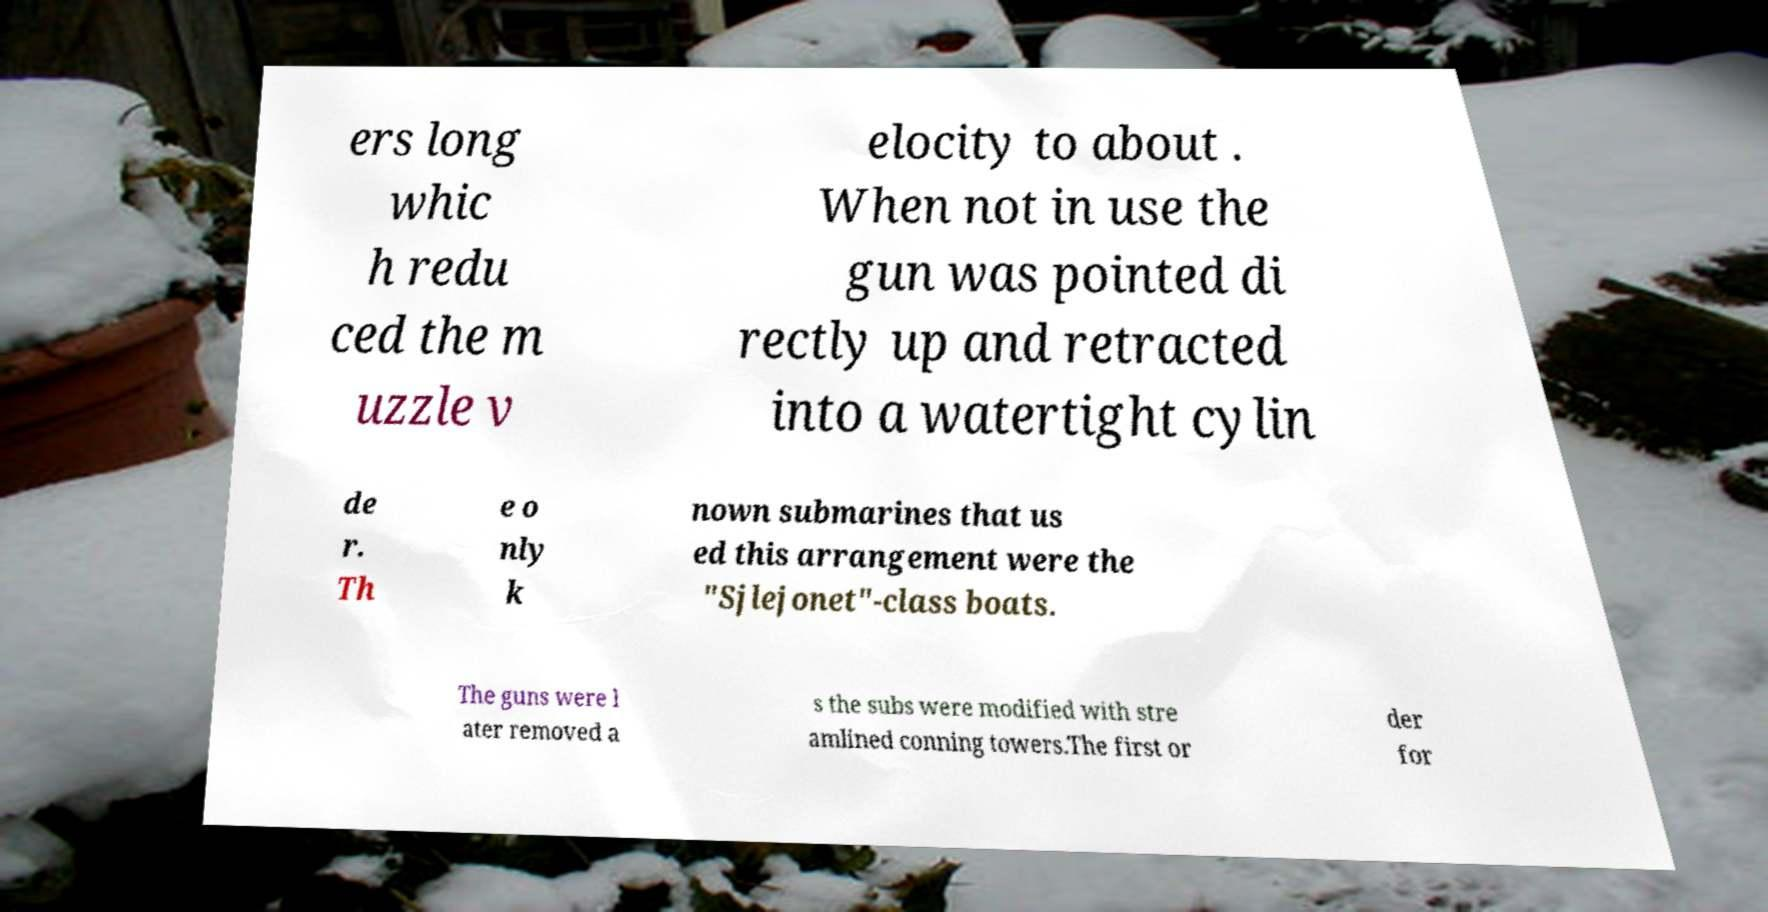Please read and relay the text visible in this image. What does it say? ers long whic h redu ced the m uzzle v elocity to about . When not in use the gun was pointed di rectly up and retracted into a watertight cylin de r. Th e o nly k nown submarines that us ed this arrangement were the "Sjlejonet"-class boats. The guns were l ater removed a s the subs were modified with stre amlined conning towers.The first or der for 